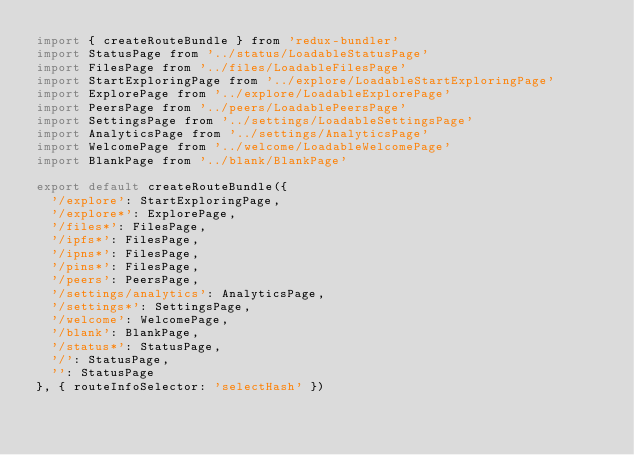Convert code to text. <code><loc_0><loc_0><loc_500><loc_500><_JavaScript_>import { createRouteBundle } from 'redux-bundler'
import StatusPage from '../status/LoadableStatusPage'
import FilesPage from '../files/LoadableFilesPage'
import StartExploringPage from '../explore/LoadableStartExploringPage'
import ExplorePage from '../explore/LoadableExplorePage'
import PeersPage from '../peers/LoadablePeersPage'
import SettingsPage from '../settings/LoadableSettingsPage'
import AnalyticsPage from '../settings/AnalyticsPage'
import WelcomePage from '../welcome/LoadableWelcomePage'
import BlankPage from '../blank/BlankPage'

export default createRouteBundle({
  '/explore': StartExploringPage,
  '/explore*': ExplorePage,
  '/files*': FilesPage,
  '/ipfs*': FilesPage,
  '/ipns*': FilesPage,
  '/pins*': FilesPage,
  '/peers': PeersPage,
  '/settings/analytics': AnalyticsPage,
  '/settings*': SettingsPage,
  '/welcome': WelcomePage,
  '/blank': BlankPage,
  '/status*': StatusPage,
  '/': StatusPage,
  '': StatusPage
}, { routeInfoSelector: 'selectHash' })
</code> 